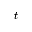Convert formula to latex. <formula><loc_0><loc_0><loc_500><loc_500>t</formula> 